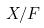<formula> <loc_0><loc_0><loc_500><loc_500>X / F</formula> 